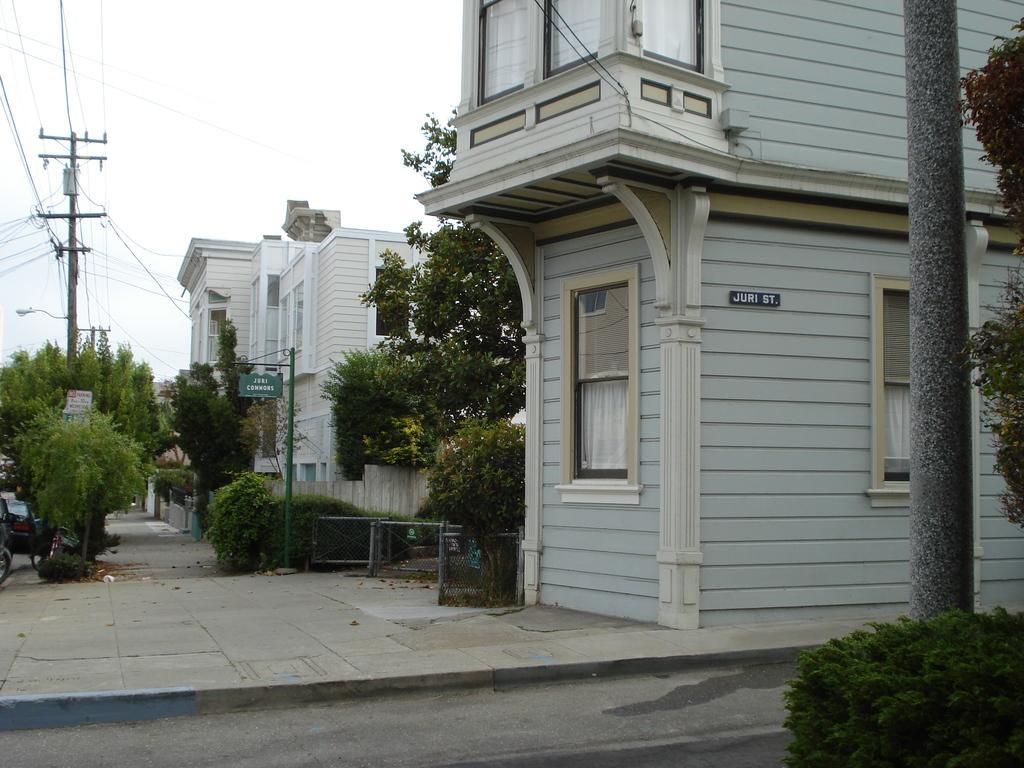How would you summarize this image in a sentence or two? In this picture we can see plants, trees, boards, poles, wires, road, mesh and buildings. In the background of the image we can see the sky. 